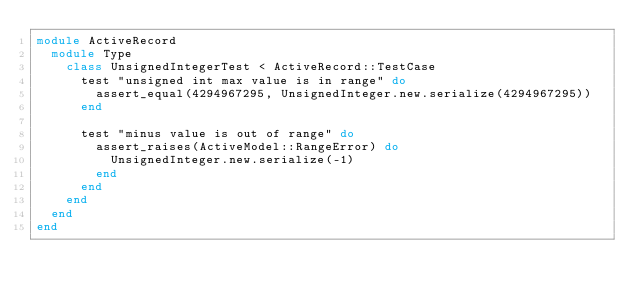Convert code to text. <code><loc_0><loc_0><loc_500><loc_500><_Ruby_>module ActiveRecord
  module Type
    class UnsignedIntegerTest < ActiveRecord::TestCase
      test "unsigned int max value is in range" do
        assert_equal(4294967295, UnsignedInteger.new.serialize(4294967295))
      end

      test "minus value is out of range" do
        assert_raises(ActiveModel::RangeError) do
          UnsignedInteger.new.serialize(-1)
        end
      end
    end
  end
end
</code> 